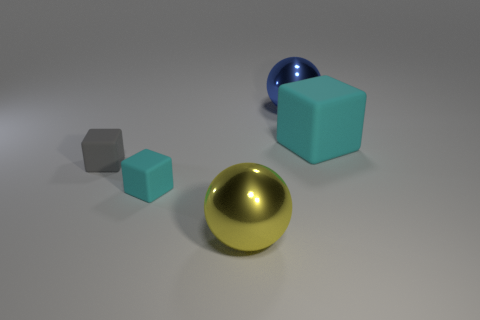There is a small object that is the same color as the large cube; what shape is it?
Your answer should be very brief. Cube. There is a thing that is on the right side of the blue shiny ball; what color is it?
Give a very brief answer. Cyan. There is a gray thing that is the same material as the big cyan thing; what size is it?
Make the answer very short. Small. Is the size of the gray matte block the same as the rubber cube that is to the right of the big yellow ball?
Offer a terse response. No. What material is the ball in front of the big rubber thing?
Your answer should be compact. Metal. There is a object in front of the small cyan matte thing; how many cyan matte blocks are to the left of it?
Give a very brief answer. 1. Are there any other things that have the same shape as the gray thing?
Your answer should be compact. Yes. Is the size of the sphere that is in front of the gray thing the same as the block to the right of the yellow sphere?
Ensure brevity in your answer.  Yes. There is a cyan object that is in front of the cyan rubber thing on the right side of the blue thing; what shape is it?
Your answer should be compact. Cube. What number of yellow metal objects are the same size as the blue ball?
Provide a short and direct response. 1. 